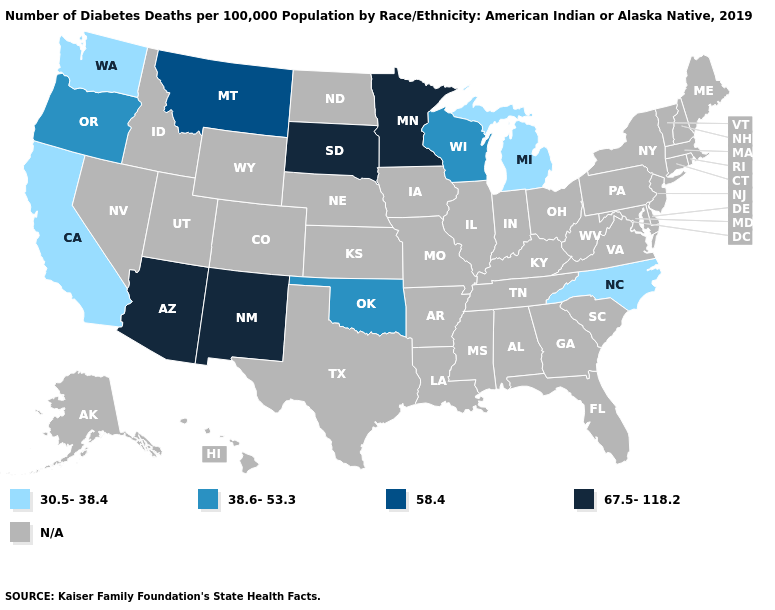Name the states that have a value in the range N/A?
Answer briefly. Alabama, Alaska, Arkansas, Colorado, Connecticut, Delaware, Florida, Georgia, Hawaii, Idaho, Illinois, Indiana, Iowa, Kansas, Kentucky, Louisiana, Maine, Maryland, Massachusetts, Mississippi, Missouri, Nebraska, Nevada, New Hampshire, New Jersey, New York, North Dakota, Ohio, Pennsylvania, Rhode Island, South Carolina, Tennessee, Texas, Utah, Vermont, Virginia, West Virginia, Wyoming. What is the value of New York?
Be succinct. N/A. Which states have the lowest value in the USA?
Write a very short answer. California, Michigan, North Carolina, Washington. Name the states that have a value in the range 58.4?
Concise answer only. Montana. What is the value of West Virginia?
Be succinct. N/A. Name the states that have a value in the range 58.4?
Be succinct. Montana. Does Oklahoma have the lowest value in the South?
Short answer required. No. Name the states that have a value in the range N/A?
Write a very short answer. Alabama, Alaska, Arkansas, Colorado, Connecticut, Delaware, Florida, Georgia, Hawaii, Idaho, Illinois, Indiana, Iowa, Kansas, Kentucky, Louisiana, Maine, Maryland, Massachusetts, Mississippi, Missouri, Nebraska, Nevada, New Hampshire, New Jersey, New York, North Dakota, Ohio, Pennsylvania, Rhode Island, South Carolina, Tennessee, Texas, Utah, Vermont, Virginia, West Virginia, Wyoming. What is the lowest value in the USA?
Keep it brief. 30.5-38.4. What is the value of Vermont?
Answer briefly. N/A. What is the lowest value in states that border South Carolina?
Be succinct. 30.5-38.4. Does Minnesota have the highest value in the MidWest?
Give a very brief answer. Yes. What is the value of Florida?
Short answer required. N/A. 